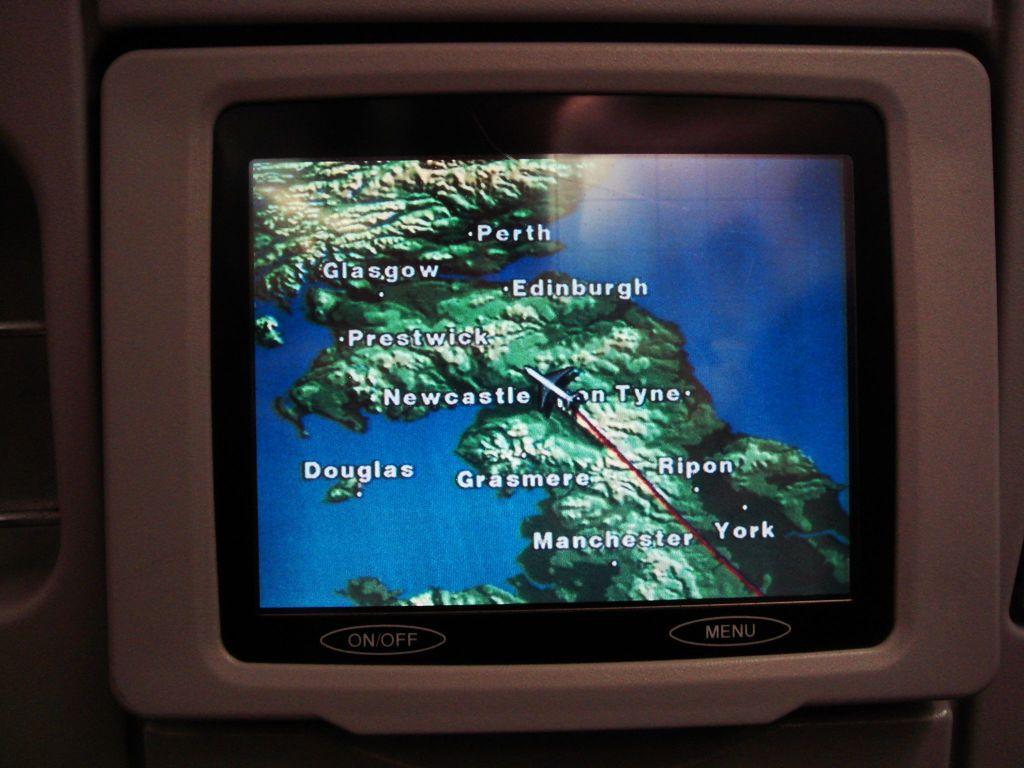<image>
Write a terse but informative summary of the picture. A screen on the back of a plane seat shows the progress of a flight over Scotland. 